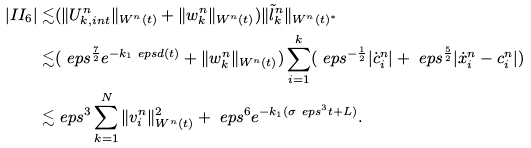<formula> <loc_0><loc_0><loc_500><loc_500>| I I _ { 6 } | \lesssim & ( \| U _ { k , i n t } ^ { n } \| _ { W ^ { n } ( t ) } + \| w _ { k } ^ { n } \| _ { W ^ { n } ( t ) } ) \| \tilde { l } _ { k } ^ { n } \| _ { W ^ { n } ( t ) ^ { * } } \\ \lesssim & ( \ e p s ^ { \frac { 7 } { 2 } } e ^ { - k _ { 1 } \ e p s d ( t ) } + \| w _ { k } ^ { n } \| _ { W ^ { n } ( t ) } ) \sum _ { i = 1 } ^ { k } ( \ e p s ^ { - \frac { 1 } { 2 } } | \dot { c } _ { i } ^ { n } | + \ e p s ^ { \frac { 5 } { 2 } } | \dot { x } _ { i } ^ { n } - c _ { i } ^ { n } | ) \\ \lesssim & \ e p s ^ { 3 } \sum _ { k = 1 } ^ { N } \| v _ { i } ^ { n } \| _ { W ^ { n } ( t ) } ^ { 2 } + \ e p s ^ { 6 } e ^ { - k _ { 1 } ( \sigma \ e p s ^ { 3 } t + L ) } .</formula> 